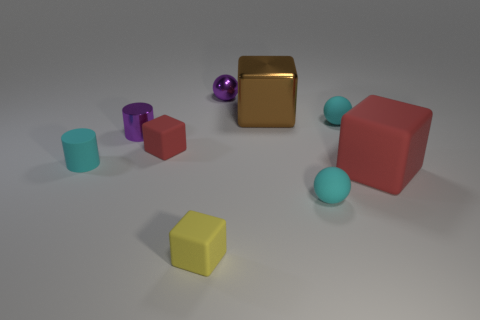What number of objects are either yellow blocks or metallic objects on the right side of the small red thing?
Keep it short and to the point. 3. There is a large cube that is in front of the big brown metallic object that is behind the cyan cylinder; what number of tiny cyan things are behind it?
Keep it short and to the point. 2. There is a red rubber object right of the large brown object; is it the same shape as the yellow matte thing?
Provide a short and direct response. Yes. There is a large thing in front of the cyan cylinder; are there any small cyan cylinders in front of it?
Provide a short and direct response. No. What number of red rubber blocks are there?
Ensure brevity in your answer.  2. The small matte thing that is to the right of the small yellow matte thing and in front of the big rubber cube is what color?
Offer a terse response. Cyan. The yellow matte thing that is the same shape as the large brown metal thing is what size?
Your answer should be compact. Small. What number of rubber things have the same size as the purple shiny ball?
Your answer should be compact. 5. What material is the yellow object?
Provide a succinct answer. Rubber. There is a tiny yellow rubber block; are there any tiny red objects to the right of it?
Make the answer very short. No. 